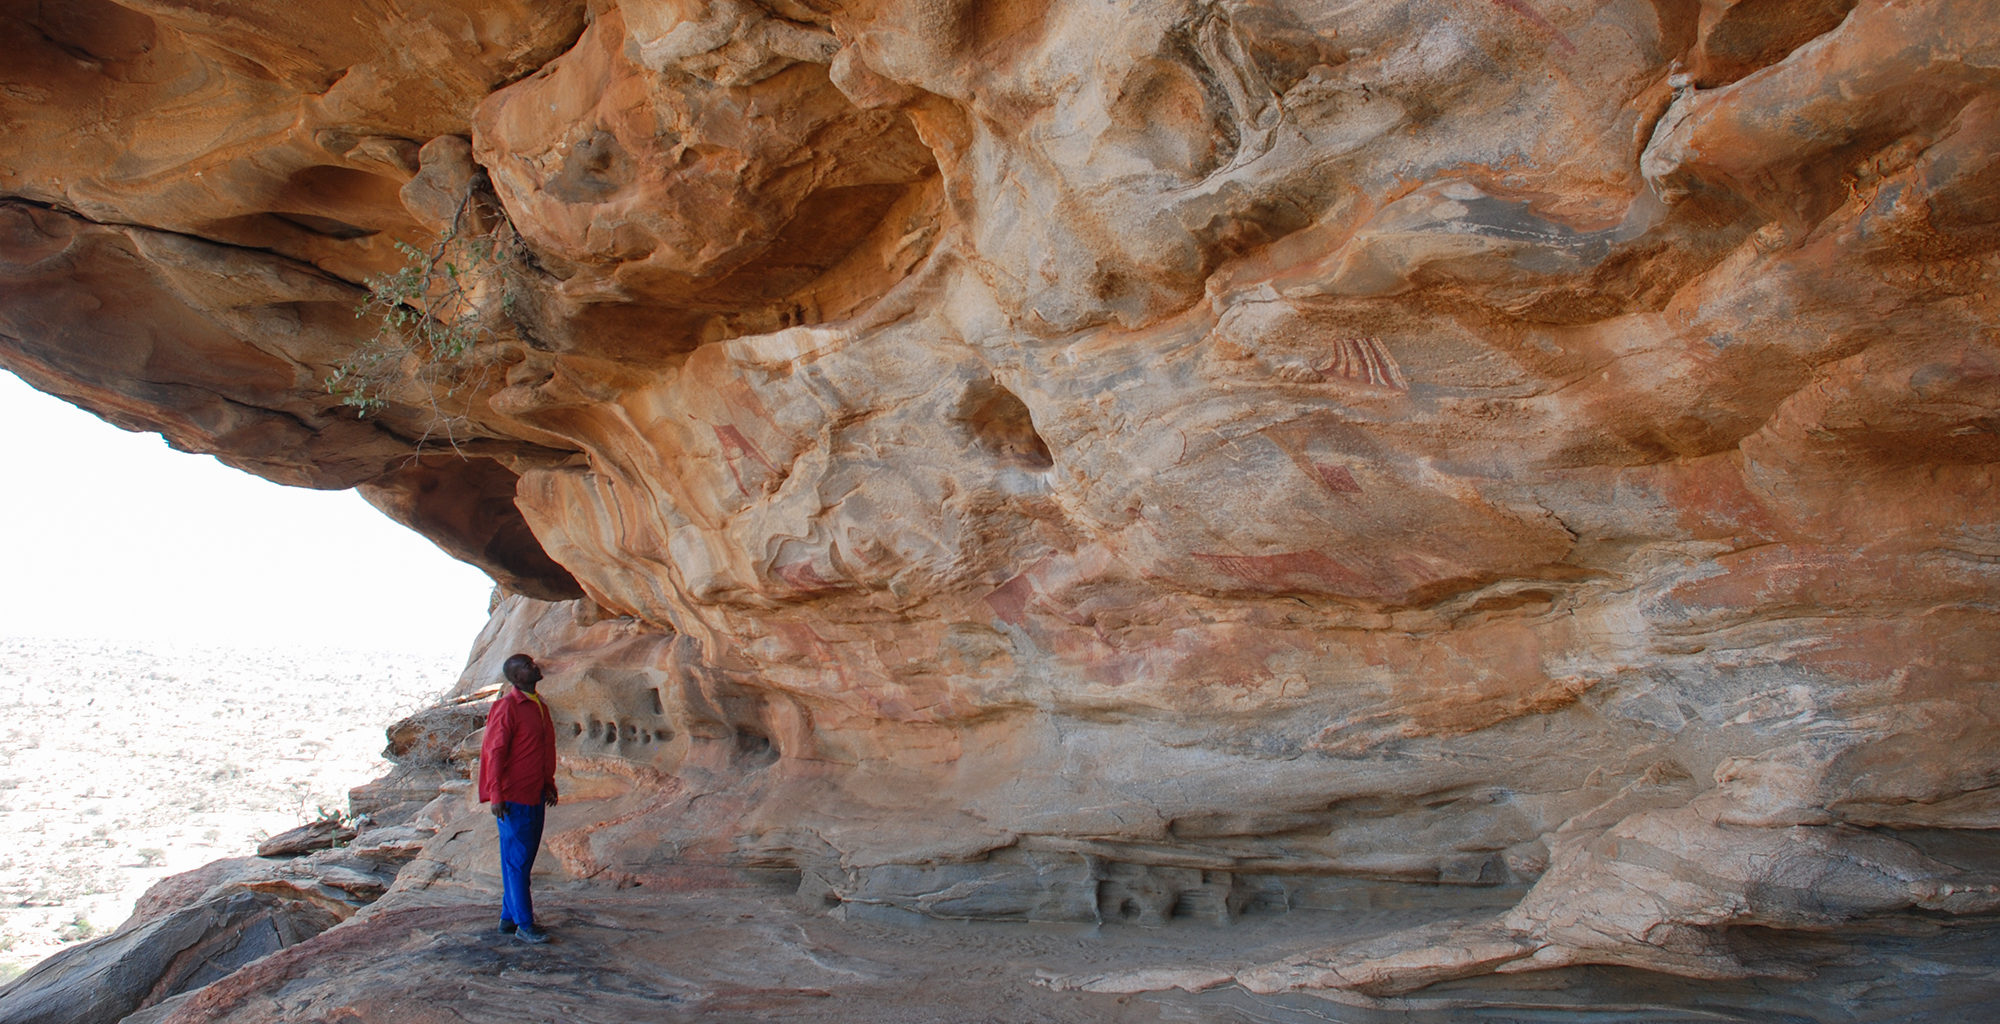What do you see happening in this image? The image showcases the Laas Geel rock art site in Somaliland. A solitary figure, absorbed in contemplation, stands on a rock ledge, gazing at the intricate ancient rock art that adorns the cave walls. The vivid white of the artwork starkly contrasts with the reddish-brown cave walls, hinting at rich stories and histories from centuries ago. The vast, desolate desert landscape stretches far into the horizon, creating a compelling backdrop that emphasizes the importance and solitude of this archaeological treasure. The perspective immerses the viewer in the scene, allowing them to share in the quiet awe and historical mystique of this significant site. 